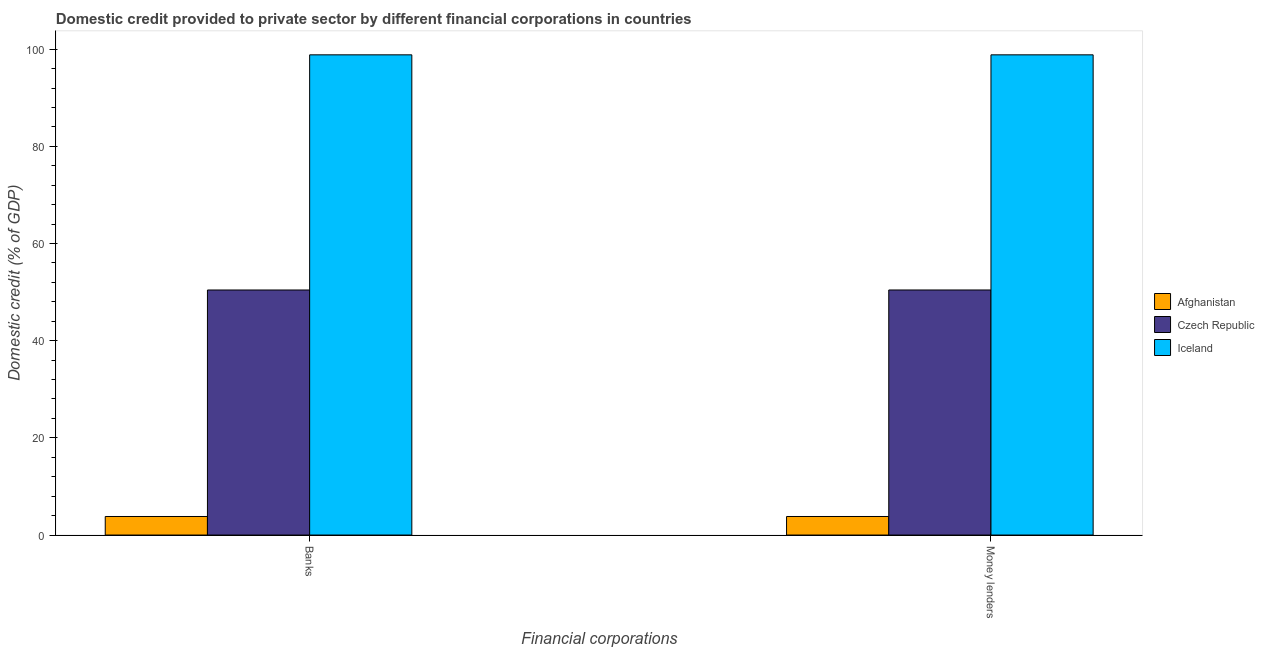How many different coloured bars are there?
Your answer should be compact. 3. How many groups of bars are there?
Provide a succinct answer. 2. Are the number of bars per tick equal to the number of legend labels?
Offer a terse response. Yes. How many bars are there on the 2nd tick from the right?
Your answer should be very brief. 3. What is the label of the 1st group of bars from the left?
Give a very brief answer. Banks. What is the domestic credit provided by money lenders in Afghanistan?
Make the answer very short. 3.82. Across all countries, what is the maximum domestic credit provided by banks?
Your answer should be very brief. 98.83. Across all countries, what is the minimum domestic credit provided by banks?
Your answer should be compact. 3.82. In which country was the domestic credit provided by money lenders minimum?
Ensure brevity in your answer.  Afghanistan. What is the total domestic credit provided by banks in the graph?
Offer a terse response. 153.09. What is the difference between the domestic credit provided by money lenders in Iceland and that in Czech Republic?
Keep it short and to the point. 48.4. What is the difference between the domestic credit provided by money lenders in Afghanistan and the domestic credit provided by banks in Iceland?
Offer a terse response. -95.02. What is the average domestic credit provided by money lenders per country?
Give a very brief answer. 51.03. What is the difference between the domestic credit provided by banks and domestic credit provided by money lenders in Afghanistan?
Make the answer very short. 0. What is the ratio of the domestic credit provided by money lenders in Czech Republic to that in Iceland?
Offer a terse response. 0.51. What does the 3rd bar from the left in Money lenders represents?
Your answer should be compact. Iceland. How many countries are there in the graph?
Your answer should be compact. 3. Are the values on the major ticks of Y-axis written in scientific E-notation?
Your response must be concise. No. Does the graph contain any zero values?
Make the answer very short. No. Where does the legend appear in the graph?
Give a very brief answer. Center right. How many legend labels are there?
Ensure brevity in your answer.  3. What is the title of the graph?
Provide a succinct answer. Domestic credit provided to private sector by different financial corporations in countries. Does "Luxembourg" appear as one of the legend labels in the graph?
Offer a terse response. No. What is the label or title of the X-axis?
Provide a succinct answer. Financial corporations. What is the label or title of the Y-axis?
Make the answer very short. Domestic credit (% of GDP). What is the Domestic credit (% of GDP) in Afghanistan in Banks?
Provide a succinct answer. 3.82. What is the Domestic credit (% of GDP) in Czech Republic in Banks?
Keep it short and to the point. 50.44. What is the Domestic credit (% of GDP) in Iceland in Banks?
Offer a terse response. 98.83. What is the Domestic credit (% of GDP) of Afghanistan in Money lenders?
Provide a short and direct response. 3.82. What is the Domestic credit (% of GDP) of Czech Republic in Money lenders?
Give a very brief answer. 50.44. What is the Domestic credit (% of GDP) in Iceland in Money lenders?
Offer a terse response. 98.83. Across all Financial corporations, what is the maximum Domestic credit (% of GDP) in Afghanistan?
Give a very brief answer. 3.82. Across all Financial corporations, what is the maximum Domestic credit (% of GDP) of Czech Republic?
Offer a terse response. 50.44. Across all Financial corporations, what is the maximum Domestic credit (% of GDP) in Iceland?
Offer a terse response. 98.83. Across all Financial corporations, what is the minimum Domestic credit (% of GDP) of Afghanistan?
Offer a terse response. 3.82. Across all Financial corporations, what is the minimum Domestic credit (% of GDP) of Czech Republic?
Give a very brief answer. 50.44. Across all Financial corporations, what is the minimum Domestic credit (% of GDP) in Iceland?
Give a very brief answer. 98.83. What is the total Domestic credit (% of GDP) of Afghanistan in the graph?
Your answer should be very brief. 7.64. What is the total Domestic credit (% of GDP) of Czech Republic in the graph?
Offer a very short reply. 100.88. What is the total Domestic credit (% of GDP) of Iceland in the graph?
Your response must be concise. 197.67. What is the difference between the Domestic credit (% of GDP) of Czech Republic in Banks and that in Money lenders?
Your response must be concise. -0. What is the difference between the Domestic credit (% of GDP) of Afghanistan in Banks and the Domestic credit (% of GDP) of Czech Republic in Money lenders?
Offer a very short reply. -46.62. What is the difference between the Domestic credit (% of GDP) in Afghanistan in Banks and the Domestic credit (% of GDP) in Iceland in Money lenders?
Your response must be concise. -95.02. What is the difference between the Domestic credit (% of GDP) of Czech Republic in Banks and the Domestic credit (% of GDP) of Iceland in Money lenders?
Your response must be concise. -48.4. What is the average Domestic credit (% of GDP) of Afghanistan per Financial corporations?
Ensure brevity in your answer.  3.82. What is the average Domestic credit (% of GDP) in Czech Republic per Financial corporations?
Offer a terse response. 50.44. What is the average Domestic credit (% of GDP) in Iceland per Financial corporations?
Offer a very short reply. 98.83. What is the difference between the Domestic credit (% of GDP) in Afghanistan and Domestic credit (% of GDP) in Czech Republic in Banks?
Provide a succinct answer. -46.62. What is the difference between the Domestic credit (% of GDP) of Afghanistan and Domestic credit (% of GDP) of Iceland in Banks?
Ensure brevity in your answer.  -95.02. What is the difference between the Domestic credit (% of GDP) of Czech Republic and Domestic credit (% of GDP) of Iceland in Banks?
Provide a succinct answer. -48.4. What is the difference between the Domestic credit (% of GDP) of Afghanistan and Domestic credit (% of GDP) of Czech Republic in Money lenders?
Ensure brevity in your answer.  -46.62. What is the difference between the Domestic credit (% of GDP) of Afghanistan and Domestic credit (% of GDP) of Iceland in Money lenders?
Offer a very short reply. -95.02. What is the difference between the Domestic credit (% of GDP) of Czech Republic and Domestic credit (% of GDP) of Iceland in Money lenders?
Make the answer very short. -48.4. What is the ratio of the Domestic credit (% of GDP) of Afghanistan in Banks to that in Money lenders?
Your response must be concise. 1. What is the difference between the highest and the second highest Domestic credit (% of GDP) in Afghanistan?
Offer a terse response. 0. What is the difference between the highest and the second highest Domestic credit (% of GDP) of Czech Republic?
Offer a very short reply. 0. What is the difference between the highest and the lowest Domestic credit (% of GDP) of Afghanistan?
Your answer should be compact. 0. What is the difference between the highest and the lowest Domestic credit (% of GDP) of Czech Republic?
Provide a succinct answer. 0. What is the difference between the highest and the lowest Domestic credit (% of GDP) of Iceland?
Give a very brief answer. 0. 